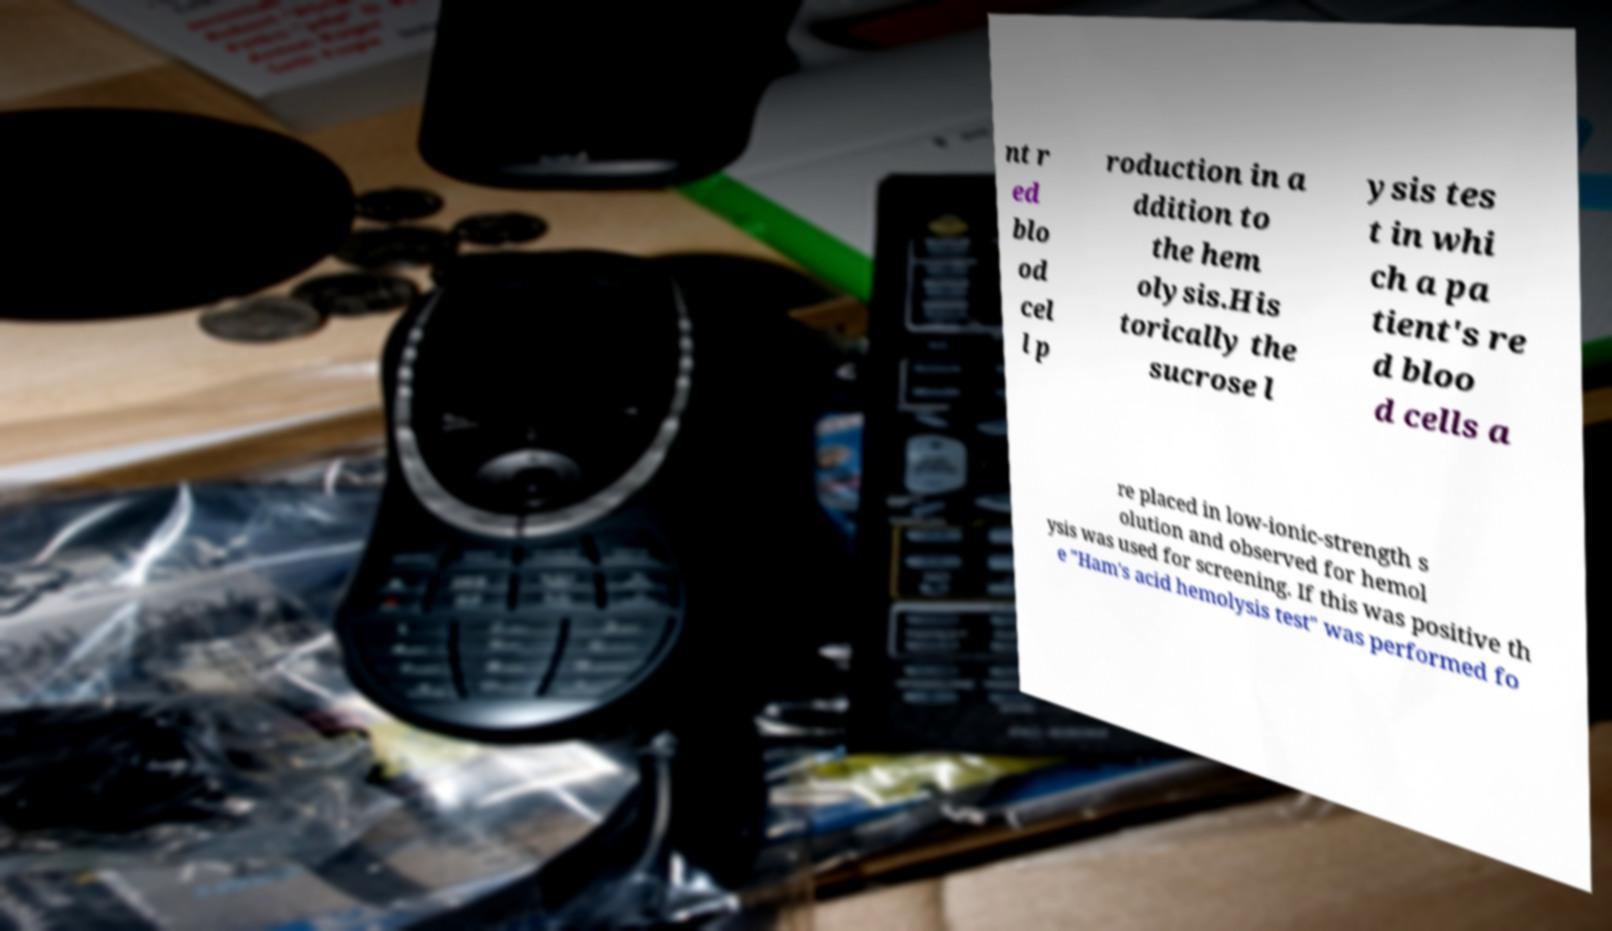Please read and relay the text visible in this image. What does it say? nt r ed blo od cel l p roduction in a ddition to the hem olysis.His torically the sucrose l ysis tes t in whi ch a pa tient's re d bloo d cells a re placed in low-ionic-strength s olution and observed for hemol ysis was used for screening. If this was positive th e "Ham's acid hemolysis test" was performed fo 